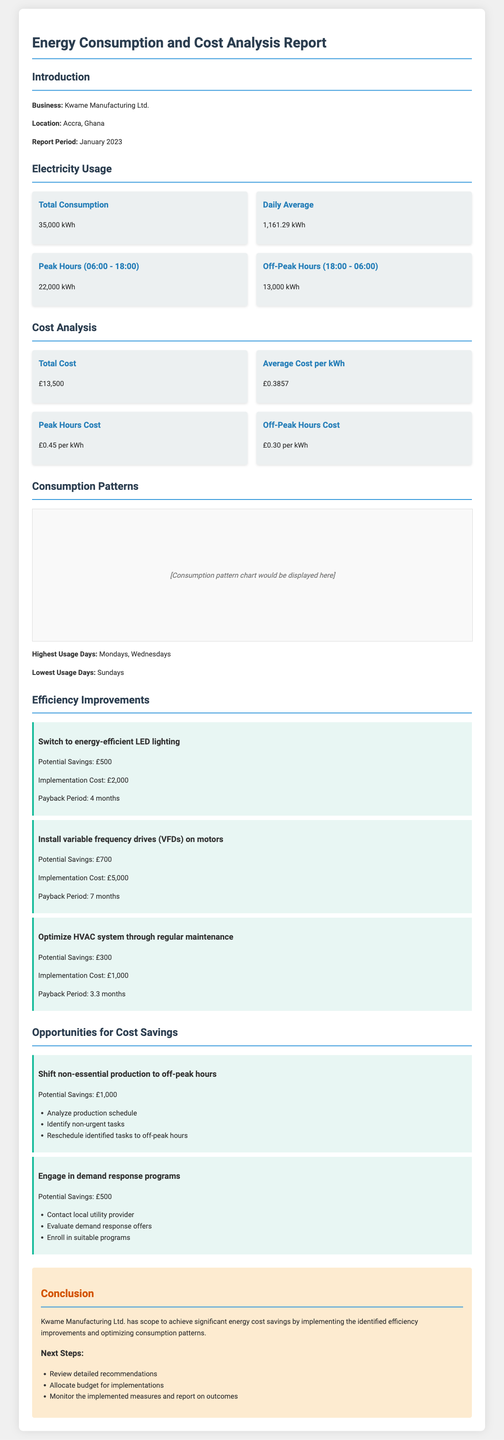What is the total electricity consumption? The total electricity consumption is provided in the document under the Electricity Usage section, specifically stating the total amount used.
Answer: 35,000 kWh What are the peak hours of usage? The document lists peak hours in the Electricity Usage section, highlighting the specific times considered peak hours based on usage.
Answer: 06:00 - 18:00 What is the average cost per kWh? The average cost per kWh is detailed in the Cost Analysis section of the document, indicating how much is charged for each kilowatt-hour.
Answer: £0.3857 What are the highest usage days? The highest usage days are specified in the Consumption Patterns section of the report, showing trends over the days of the week.
Answer: Mondays, Wednesdays How much can be saved by switching to energy-efficient LED lighting? The potential savings from implementing this solution are outlined in the Efficiency Improvements section, indicating financial benefits.
Answer: £500 What is the total cost of electricity for January 2023? The total cost of electricity is stated in the Cost Analysis section, summarizing the overall expenditure incurred for the report period.
Answer: £13,500 How long is the payback period for installing variable frequency drives (VFDs)? The payback period for the VFDs is detailed in the Efficiency Improvements section, offering insight into the time frame for financial recovery on investment.
Answer: 7 months What is one opportunity for cost savings mentioned? The document lists various opportunities for cost savings in the Opportunities for Cost Savings section, detailing specific strategies that can be implemented.
Answer: Shift non-essential production to off-peak hours 